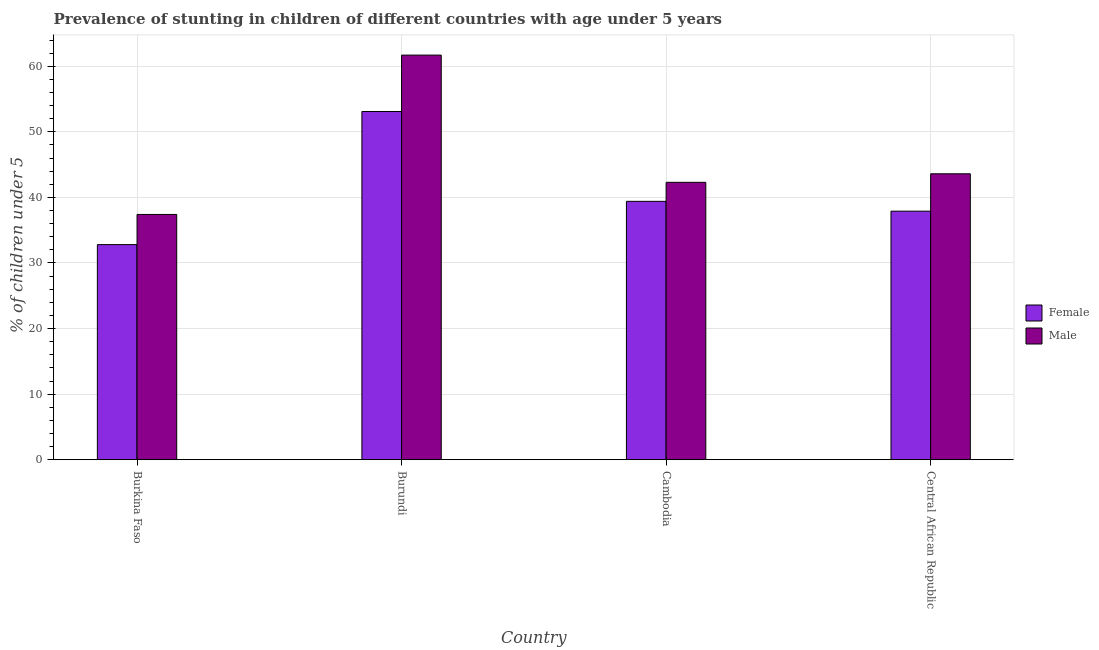Are the number of bars on each tick of the X-axis equal?
Your response must be concise. Yes. How many bars are there on the 4th tick from the left?
Offer a terse response. 2. How many bars are there on the 1st tick from the right?
Offer a terse response. 2. What is the label of the 3rd group of bars from the left?
Ensure brevity in your answer.  Cambodia. In how many cases, is the number of bars for a given country not equal to the number of legend labels?
Provide a succinct answer. 0. What is the percentage of stunted male children in Central African Republic?
Your answer should be very brief. 43.6. Across all countries, what is the maximum percentage of stunted male children?
Offer a very short reply. 61.7. Across all countries, what is the minimum percentage of stunted female children?
Give a very brief answer. 32.8. In which country was the percentage of stunted female children maximum?
Provide a succinct answer. Burundi. In which country was the percentage of stunted male children minimum?
Offer a very short reply. Burkina Faso. What is the total percentage of stunted female children in the graph?
Provide a succinct answer. 163.2. What is the difference between the percentage of stunted female children in Burkina Faso and that in Burundi?
Provide a short and direct response. -20.3. What is the difference between the percentage of stunted female children in Cambodia and the percentage of stunted male children in Central African Republic?
Provide a succinct answer. -4.2. What is the average percentage of stunted female children per country?
Your answer should be very brief. 40.8. What is the difference between the percentage of stunted female children and percentage of stunted male children in Central African Republic?
Your answer should be compact. -5.7. What is the ratio of the percentage of stunted female children in Burkina Faso to that in Central African Republic?
Offer a very short reply. 0.87. What is the difference between the highest and the second highest percentage of stunted female children?
Ensure brevity in your answer.  13.7. What is the difference between the highest and the lowest percentage of stunted male children?
Ensure brevity in your answer.  24.3. What does the 2nd bar from the left in Central African Republic represents?
Your response must be concise. Male. Are all the bars in the graph horizontal?
Give a very brief answer. No. Are the values on the major ticks of Y-axis written in scientific E-notation?
Provide a short and direct response. No. What is the title of the graph?
Your answer should be very brief. Prevalence of stunting in children of different countries with age under 5 years. What is the label or title of the Y-axis?
Give a very brief answer.  % of children under 5. What is the  % of children under 5 of Female in Burkina Faso?
Give a very brief answer. 32.8. What is the  % of children under 5 of Male in Burkina Faso?
Keep it short and to the point. 37.4. What is the  % of children under 5 in Female in Burundi?
Make the answer very short. 53.1. What is the  % of children under 5 in Male in Burundi?
Keep it short and to the point. 61.7. What is the  % of children under 5 of Female in Cambodia?
Offer a very short reply. 39.4. What is the  % of children under 5 of Male in Cambodia?
Offer a terse response. 42.3. What is the  % of children under 5 in Female in Central African Republic?
Your answer should be very brief. 37.9. What is the  % of children under 5 in Male in Central African Republic?
Ensure brevity in your answer.  43.6. Across all countries, what is the maximum  % of children under 5 in Female?
Give a very brief answer. 53.1. Across all countries, what is the maximum  % of children under 5 in Male?
Provide a succinct answer. 61.7. Across all countries, what is the minimum  % of children under 5 of Female?
Give a very brief answer. 32.8. Across all countries, what is the minimum  % of children under 5 in Male?
Ensure brevity in your answer.  37.4. What is the total  % of children under 5 of Female in the graph?
Give a very brief answer. 163.2. What is the total  % of children under 5 in Male in the graph?
Give a very brief answer. 185. What is the difference between the  % of children under 5 of Female in Burkina Faso and that in Burundi?
Offer a terse response. -20.3. What is the difference between the  % of children under 5 in Male in Burkina Faso and that in Burundi?
Make the answer very short. -24.3. What is the difference between the  % of children under 5 in Male in Burkina Faso and that in Cambodia?
Provide a succinct answer. -4.9. What is the difference between the  % of children under 5 of Male in Burkina Faso and that in Central African Republic?
Make the answer very short. -6.2. What is the difference between the  % of children under 5 in Female in Burundi and that in Cambodia?
Keep it short and to the point. 13.7. What is the difference between the  % of children under 5 in Male in Burundi and that in Central African Republic?
Keep it short and to the point. 18.1. What is the difference between the  % of children under 5 in Female in Burkina Faso and the  % of children under 5 in Male in Burundi?
Your answer should be compact. -28.9. What is the difference between the  % of children under 5 of Female in Burundi and the  % of children under 5 of Male in Cambodia?
Ensure brevity in your answer.  10.8. What is the difference between the  % of children under 5 in Female in Cambodia and the  % of children under 5 in Male in Central African Republic?
Your answer should be compact. -4.2. What is the average  % of children under 5 of Female per country?
Give a very brief answer. 40.8. What is the average  % of children under 5 in Male per country?
Ensure brevity in your answer.  46.25. What is the difference between the  % of children under 5 of Female and  % of children under 5 of Male in Burkina Faso?
Offer a terse response. -4.6. What is the difference between the  % of children under 5 in Female and  % of children under 5 in Male in Burundi?
Your answer should be compact. -8.6. What is the difference between the  % of children under 5 of Female and  % of children under 5 of Male in Central African Republic?
Your answer should be compact. -5.7. What is the ratio of the  % of children under 5 in Female in Burkina Faso to that in Burundi?
Make the answer very short. 0.62. What is the ratio of the  % of children under 5 of Male in Burkina Faso to that in Burundi?
Your answer should be compact. 0.61. What is the ratio of the  % of children under 5 of Female in Burkina Faso to that in Cambodia?
Your answer should be very brief. 0.83. What is the ratio of the  % of children under 5 in Male in Burkina Faso to that in Cambodia?
Provide a short and direct response. 0.88. What is the ratio of the  % of children under 5 in Female in Burkina Faso to that in Central African Republic?
Provide a succinct answer. 0.87. What is the ratio of the  % of children under 5 in Male in Burkina Faso to that in Central African Republic?
Offer a terse response. 0.86. What is the ratio of the  % of children under 5 of Female in Burundi to that in Cambodia?
Provide a short and direct response. 1.35. What is the ratio of the  % of children under 5 in Male in Burundi to that in Cambodia?
Ensure brevity in your answer.  1.46. What is the ratio of the  % of children under 5 of Female in Burundi to that in Central African Republic?
Provide a succinct answer. 1.4. What is the ratio of the  % of children under 5 of Male in Burundi to that in Central African Republic?
Your answer should be compact. 1.42. What is the ratio of the  % of children under 5 in Female in Cambodia to that in Central African Republic?
Give a very brief answer. 1.04. What is the ratio of the  % of children under 5 in Male in Cambodia to that in Central African Republic?
Provide a short and direct response. 0.97. What is the difference between the highest and the second highest  % of children under 5 of Female?
Your answer should be very brief. 13.7. What is the difference between the highest and the lowest  % of children under 5 in Female?
Offer a terse response. 20.3. What is the difference between the highest and the lowest  % of children under 5 of Male?
Offer a very short reply. 24.3. 